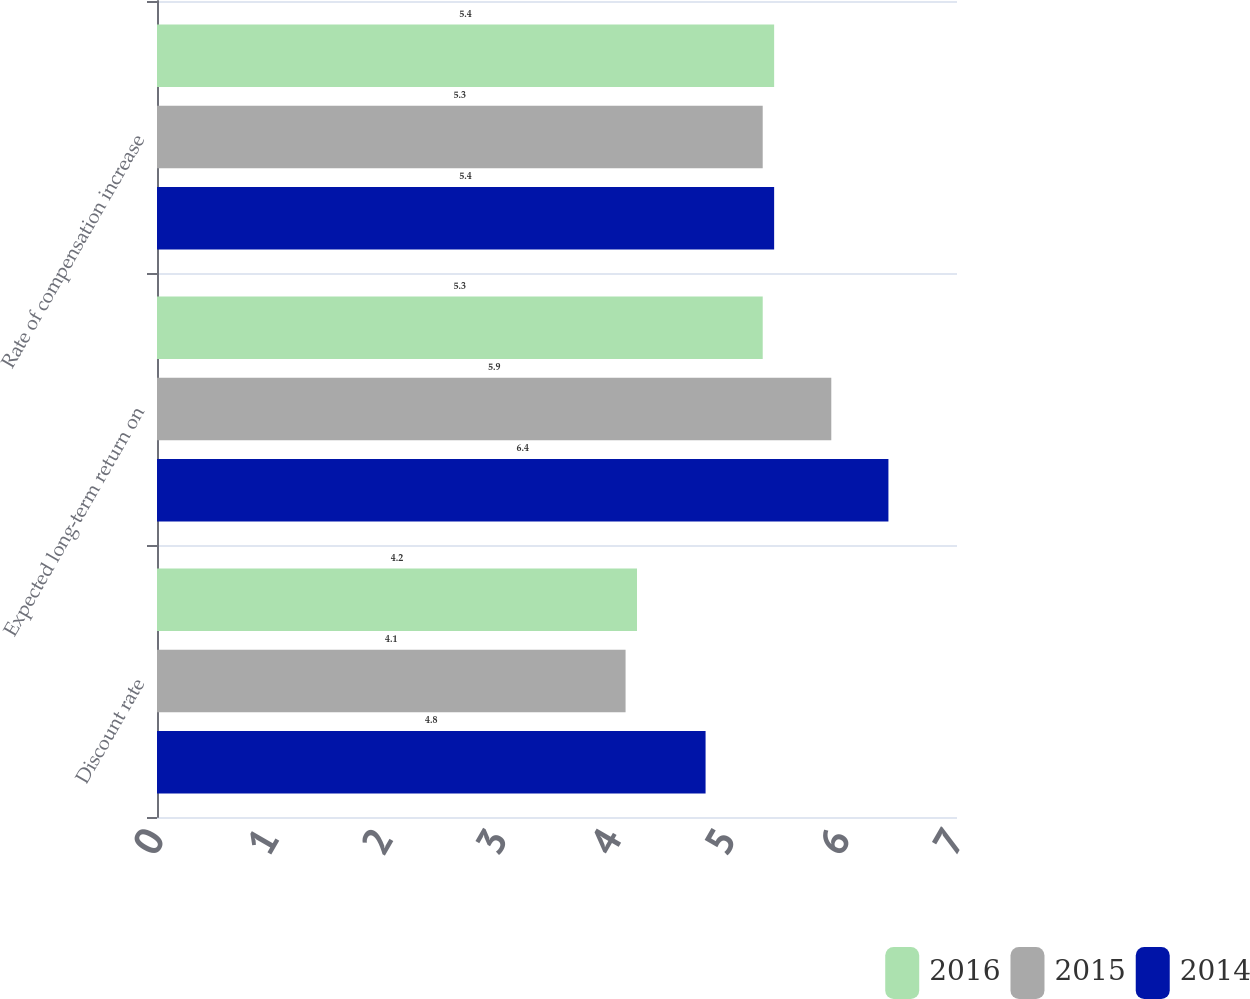Convert chart to OTSL. <chart><loc_0><loc_0><loc_500><loc_500><stacked_bar_chart><ecel><fcel>Discount rate<fcel>Expected long-term return on<fcel>Rate of compensation increase<nl><fcel>2016<fcel>4.2<fcel>5.3<fcel>5.4<nl><fcel>2015<fcel>4.1<fcel>5.9<fcel>5.3<nl><fcel>2014<fcel>4.8<fcel>6.4<fcel>5.4<nl></chart> 